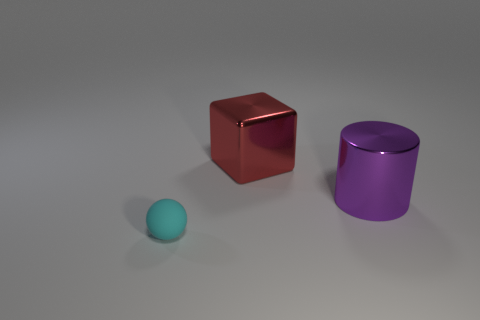How many other things are there of the same material as the cyan ball?
Provide a short and direct response. 0. Is the number of large metal objects in front of the cylinder greater than the number of large cylinders that are to the left of the tiny cyan ball?
Provide a succinct answer. No. How many large metallic things are to the right of the shiny cylinder?
Ensure brevity in your answer.  0. Is the material of the big cube the same as the thing that is to the left of the cube?
Ensure brevity in your answer.  No. Are there any other things that are the same shape as the big purple shiny thing?
Provide a succinct answer. No. Are the big cylinder and the tiny cyan ball made of the same material?
Offer a terse response. No. Are there any cyan matte spheres to the right of the thing that is in front of the cylinder?
Keep it short and to the point. No. How many objects are in front of the cube and to the right of the cyan thing?
Offer a terse response. 1. What is the shape of the large shiny thing that is on the right side of the red object?
Give a very brief answer. Cylinder. What number of shiny blocks are the same size as the shiny cylinder?
Your response must be concise. 1. 